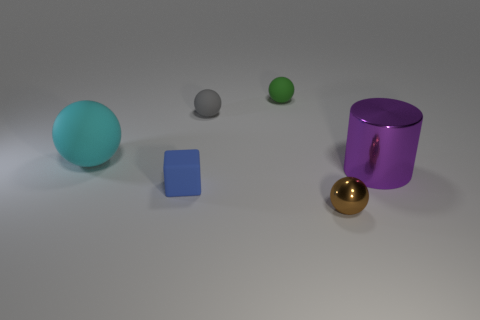What is the material of the ball in front of the big object right of the brown ball?
Offer a very short reply. Metal. The thing that is both in front of the big cyan object and behind the tiny blue object has what shape?
Make the answer very short. Cylinder. There is a brown object that is the same shape as the green thing; what is its size?
Provide a short and direct response. Small. Is the number of big metal things that are in front of the large purple metal cylinder less than the number of tiny green spheres?
Provide a succinct answer. Yes. There is a rubber object that is in front of the purple thing; what size is it?
Your response must be concise. Small. What is the color of the small metal thing that is the same shape as the cyan matte thing?
Your response must be concise. Brown. How many rubber objects are the same color as the large rubber sphere?
Offer a very short reply. 0. Is there any other thing that has the same shape as the large cyan rubber thing?
Ensure brevity in your answer.  Yes. Is there a small brown ball that is to the right of the big thing that is right of the matte object in front of the big metallic cylinder?
Make the answer very short. No. What number of other tiny blocks have the same material as the blue block?
Offer a very short reply. 0. 